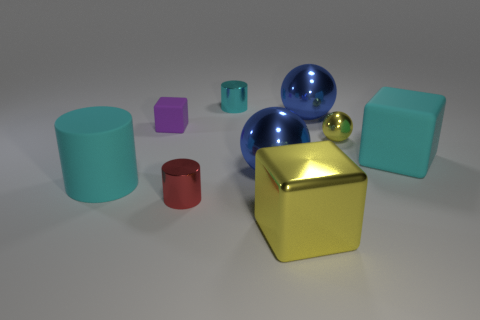The large matte cube is what color?
Provide a short and direct response. Cyan. The block that is the same material as the yellow sphere is what size?
Provide a short and direct response. Large. There is a cyan matte thing that is on the right side of the big cyan rubber cylinder that is in front of the tiny matte object; how many matte objects are on the left side of it?
Provide a succinct answer. 2. There is a rubber cylinder; is its color the same as the small metal cylinder behind the tiny purple matte cube?
Offer a terse response. Yes. There is a metallic thing that is the same color as the small ball; what shape is it?
Your response must be concise. Cube. What material is the large object left of the metallic cylinder that is behind the tiny shiny cylinder in front of the tiny matte thing?
Give a very brief answer. Rubber. Do the large thing that is to the left of the tiny red shiny object and the small matte object have the same shape?
Give a very brief answer. No. There is a cyan object to the left of the purple block; what material is it?
Provide a short and direct response. Rubber. What number of shiny objects are either purple blocks or cyan cylinders?
Give a very brief answer. 1. Is there a blue sphere of the same size as the cyan rubber block?
Provide a succinct answer. Yes. 